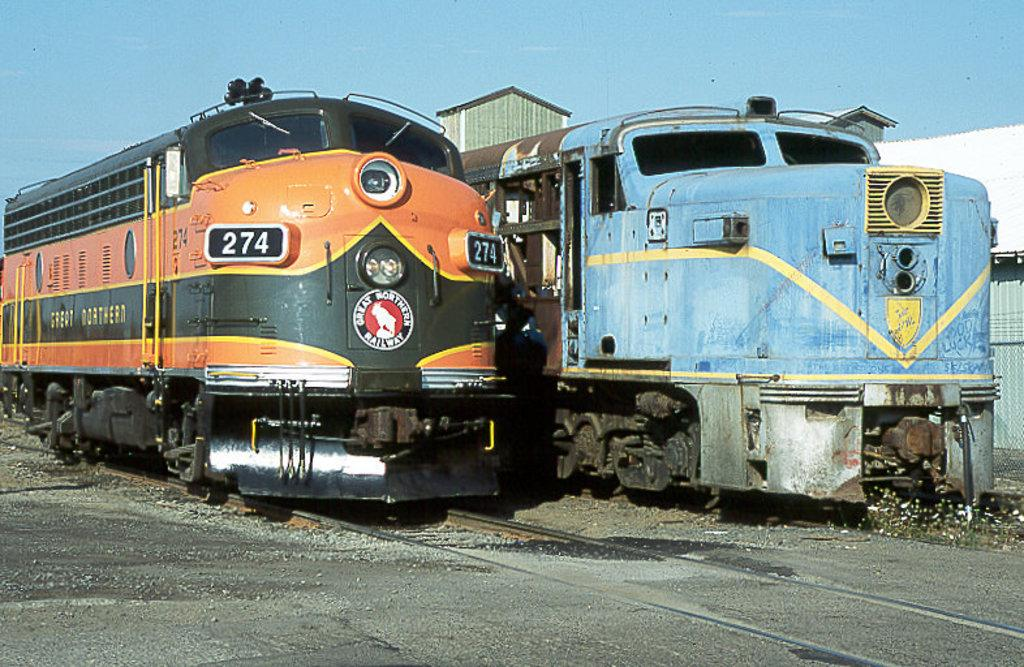What can be seen in the image that is related to transportation? There are two train engines in the image. How are the train engines positioned in the image? The train engines are beside each other. What is the surface on which the train engines are placed? There is a railway track at the bottom of the image. What is visible at the top of the image? The sky is visible at the top of the image. What can be seen in the background of the image? There is a building in the background of the image. What type of celery is being used as a decoration on the train engines? There is no celery present in the image; it is a picture of train engines and a railway track. How does the rice contribute to the functionality of the train engines? There is no rice present in the image, and it does not affect the functionality of the train engines. 